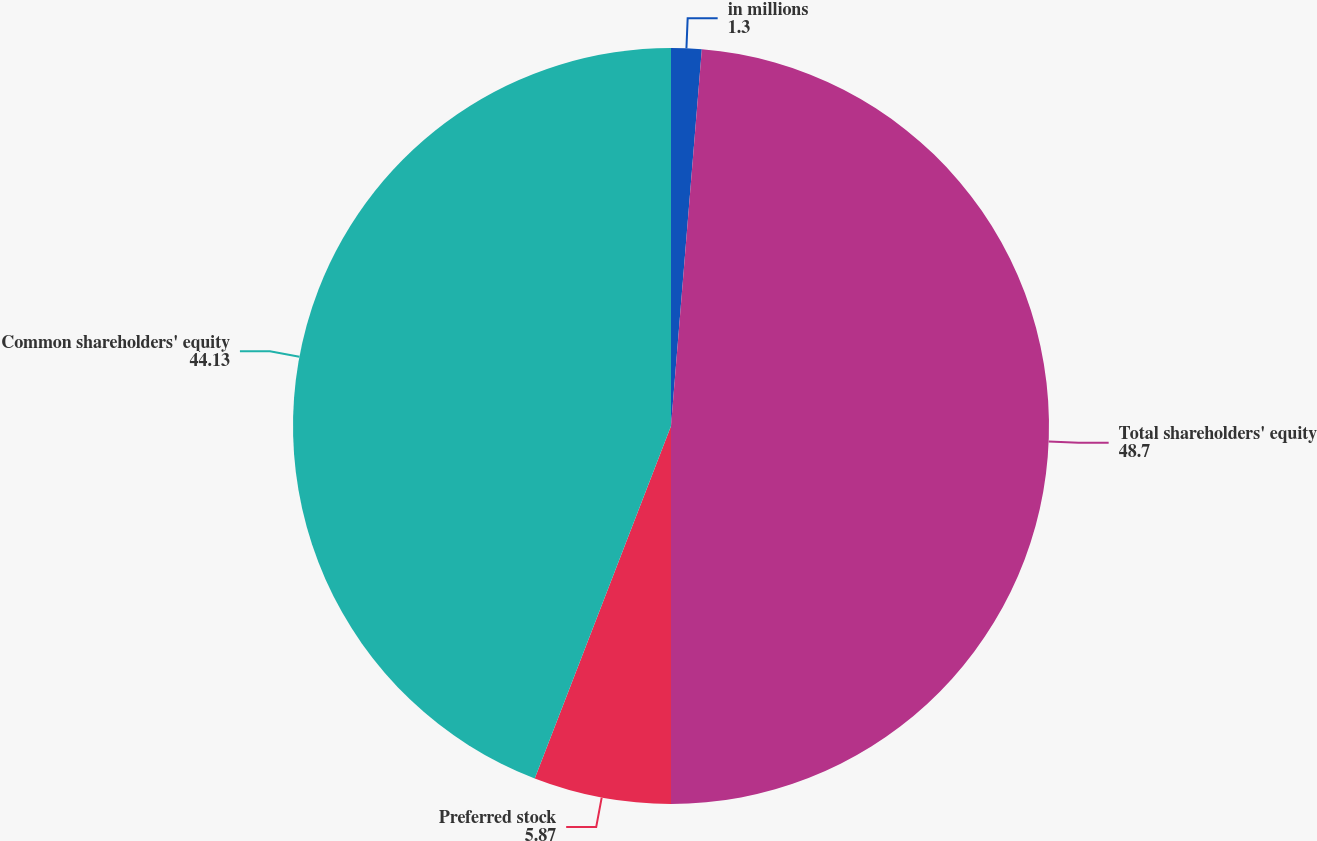Convert chart. <chart><loc_0><loc_0><loc_500><loc_500><pie_chart><fcel>in millions<fcel>Total shareholders' equity<fcel>Preferred stock<fcel>Common shareholders' equity<nl><fcel>1.3%<fcel>48.7%<fcel>5.87%<fcel>44.13%<nl></chart> 